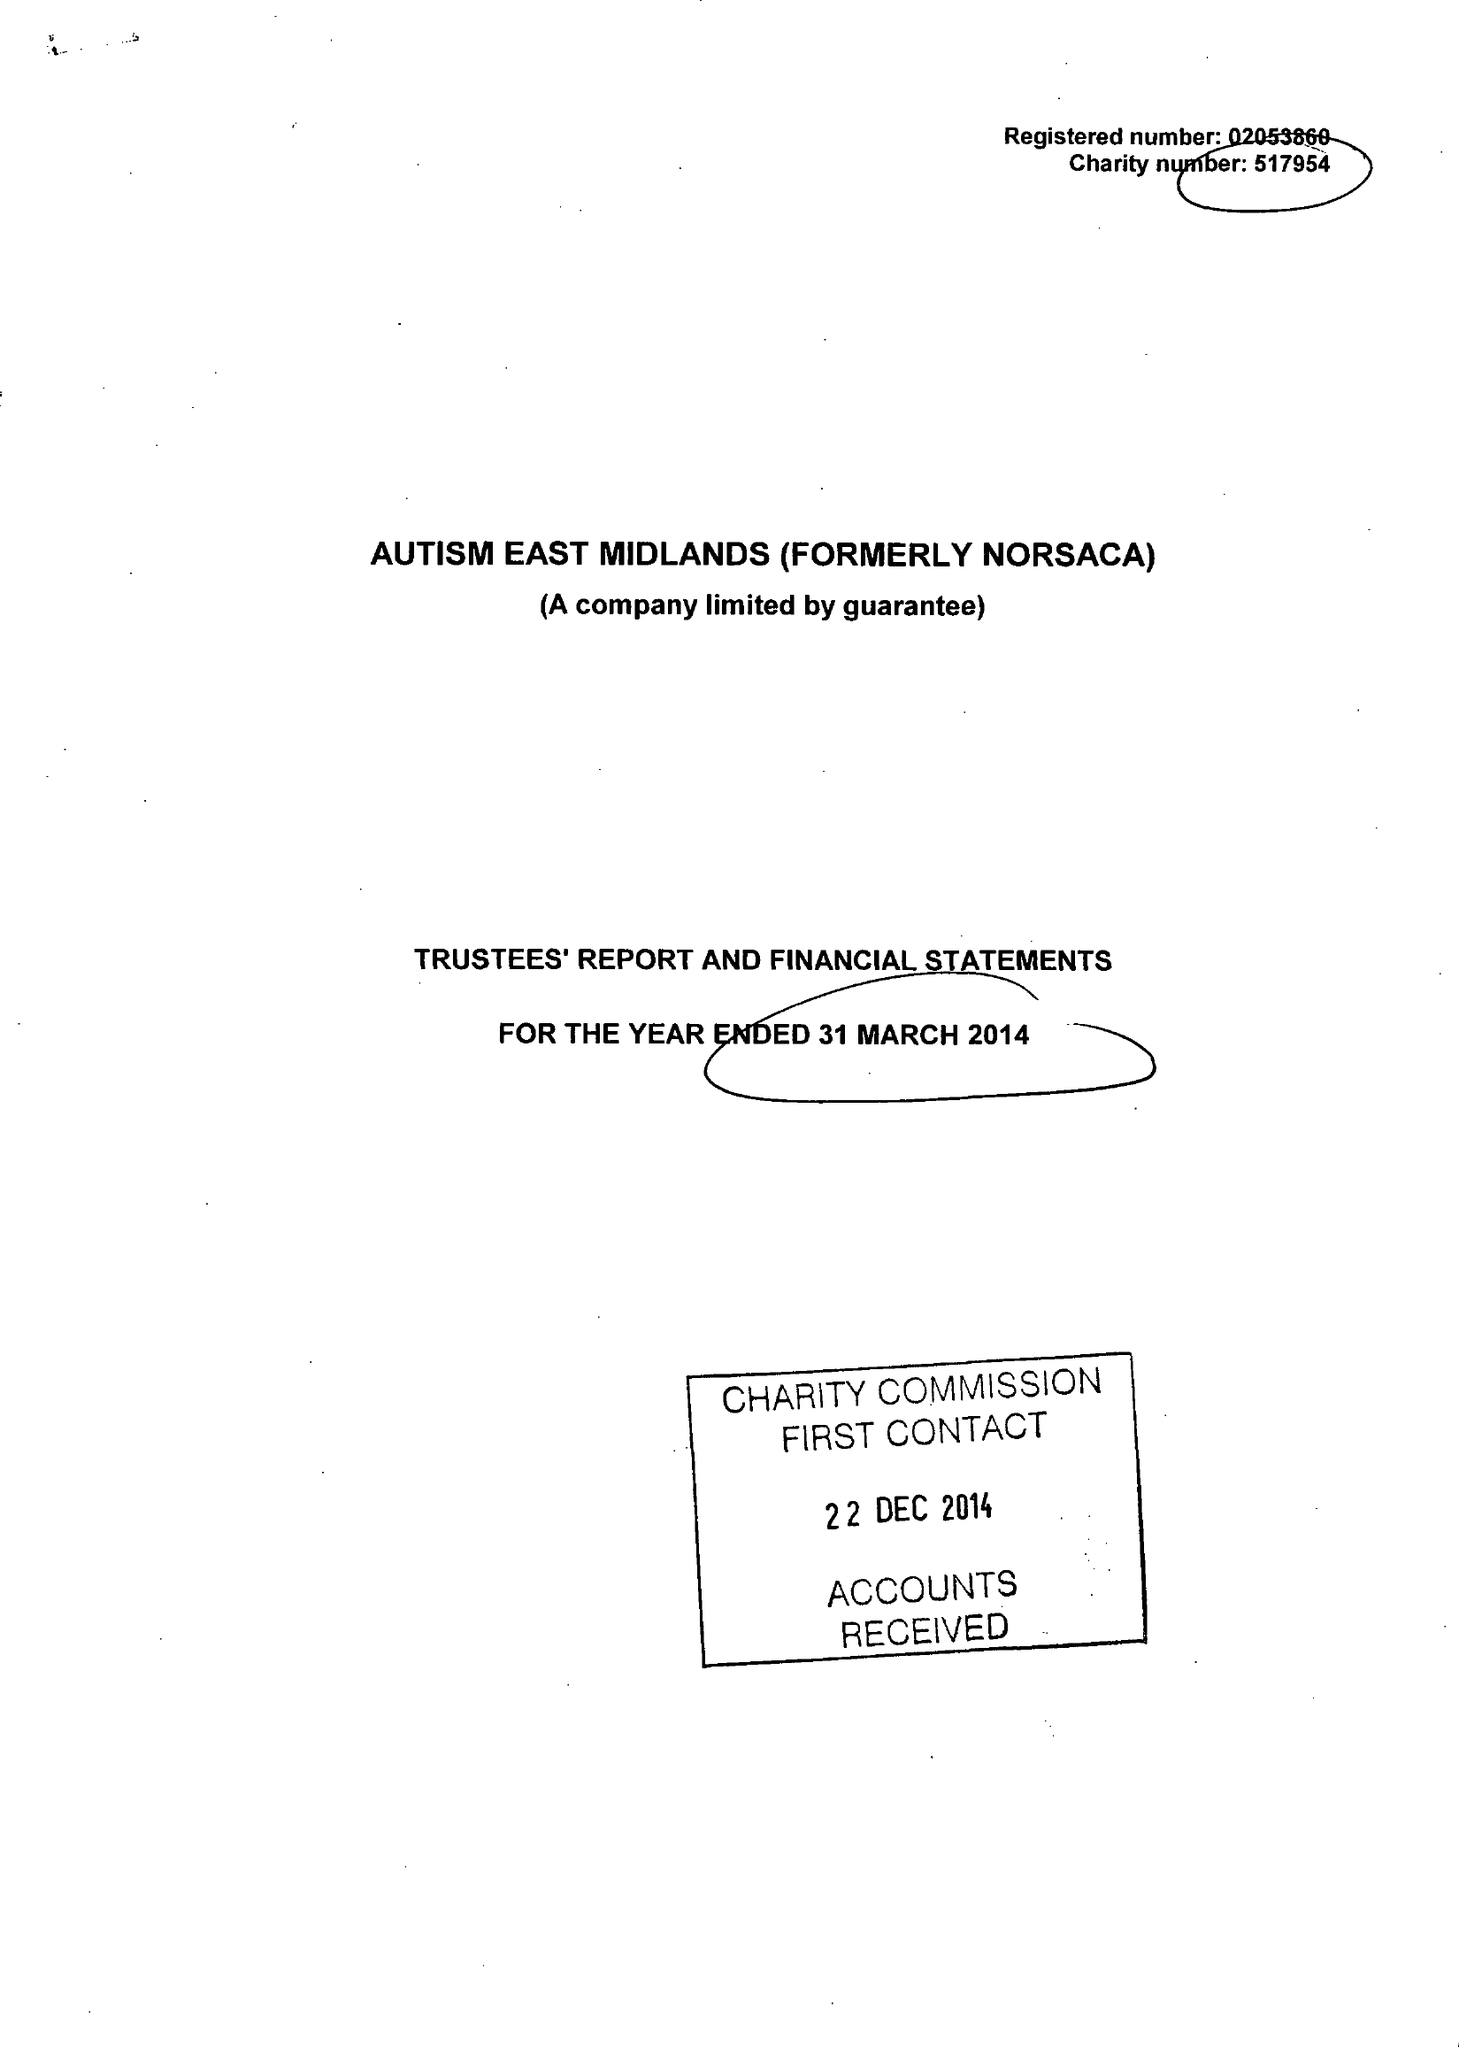What is the value for the spending_annually_in_british_pounds?
Answer the question using a single word or phrase. 12443663.00 